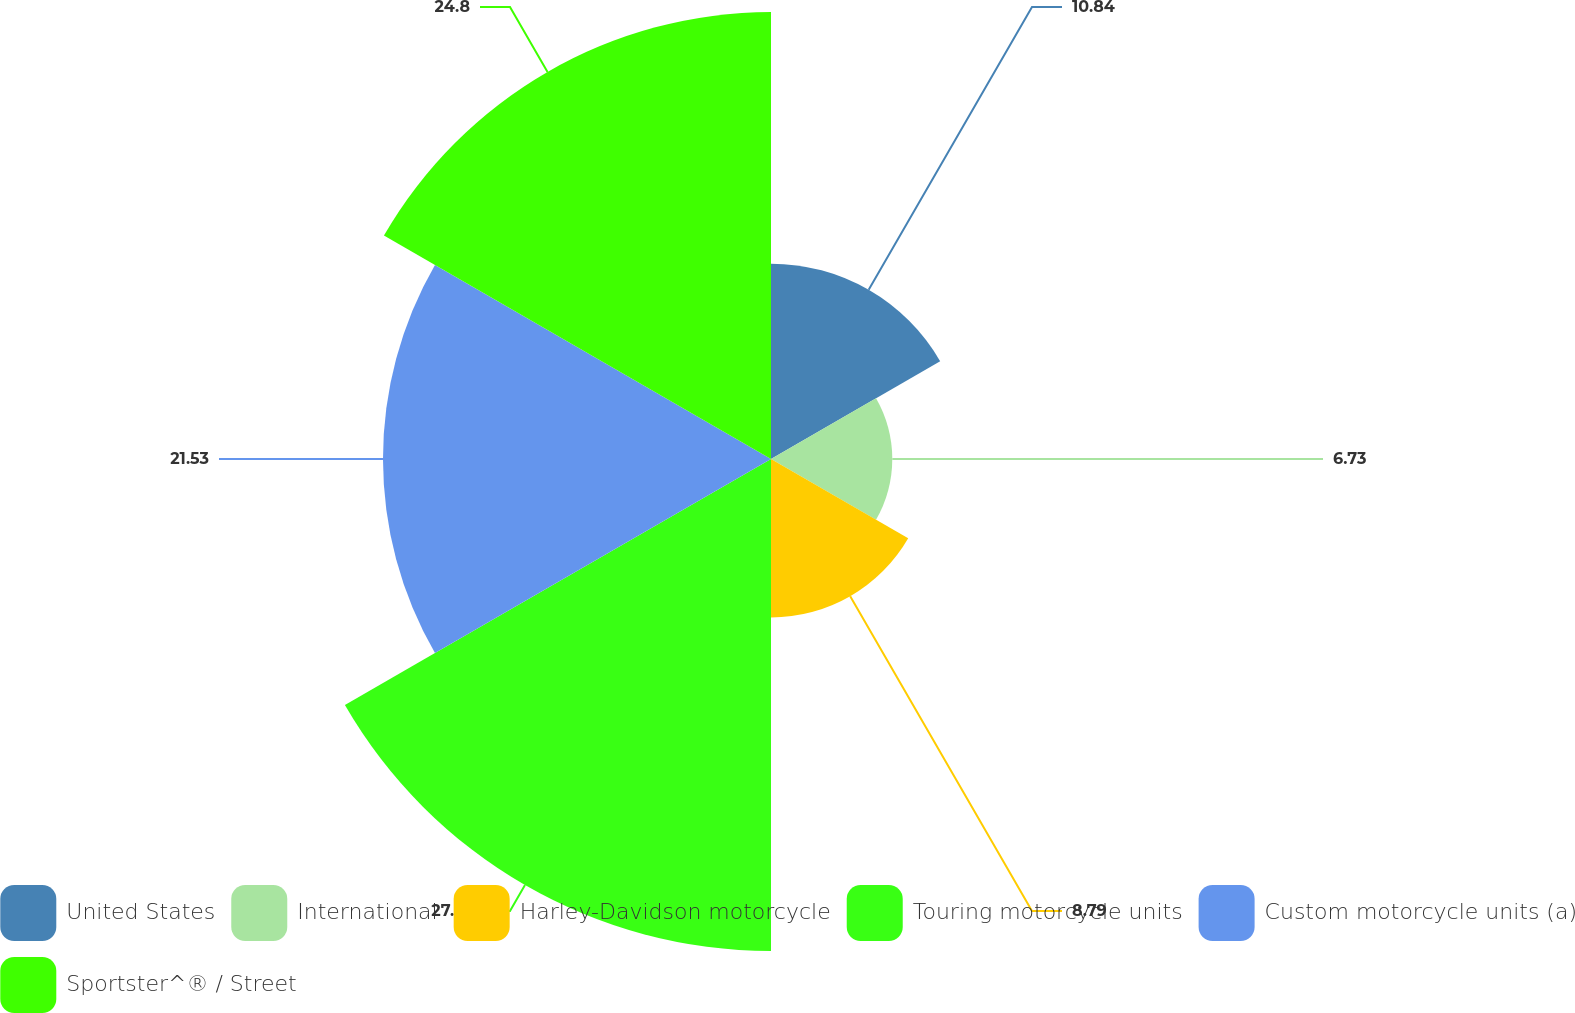<chart> <loc_0><loc_0><loc_500><loc_500><pie_chart><fcel>United States<fcel>International<fcel>Harley-Davidson motorcycle<fcel>Touring motorcycle units<fcel>Custom motorcycle units (a)<fcel>Sportster^® / Street<nl><fcel>10.84%<fcel>6.73%<fcel>8.79%<fcel>27.3%<fcel>21.53%<fcel>24.8%<nl></chart> 